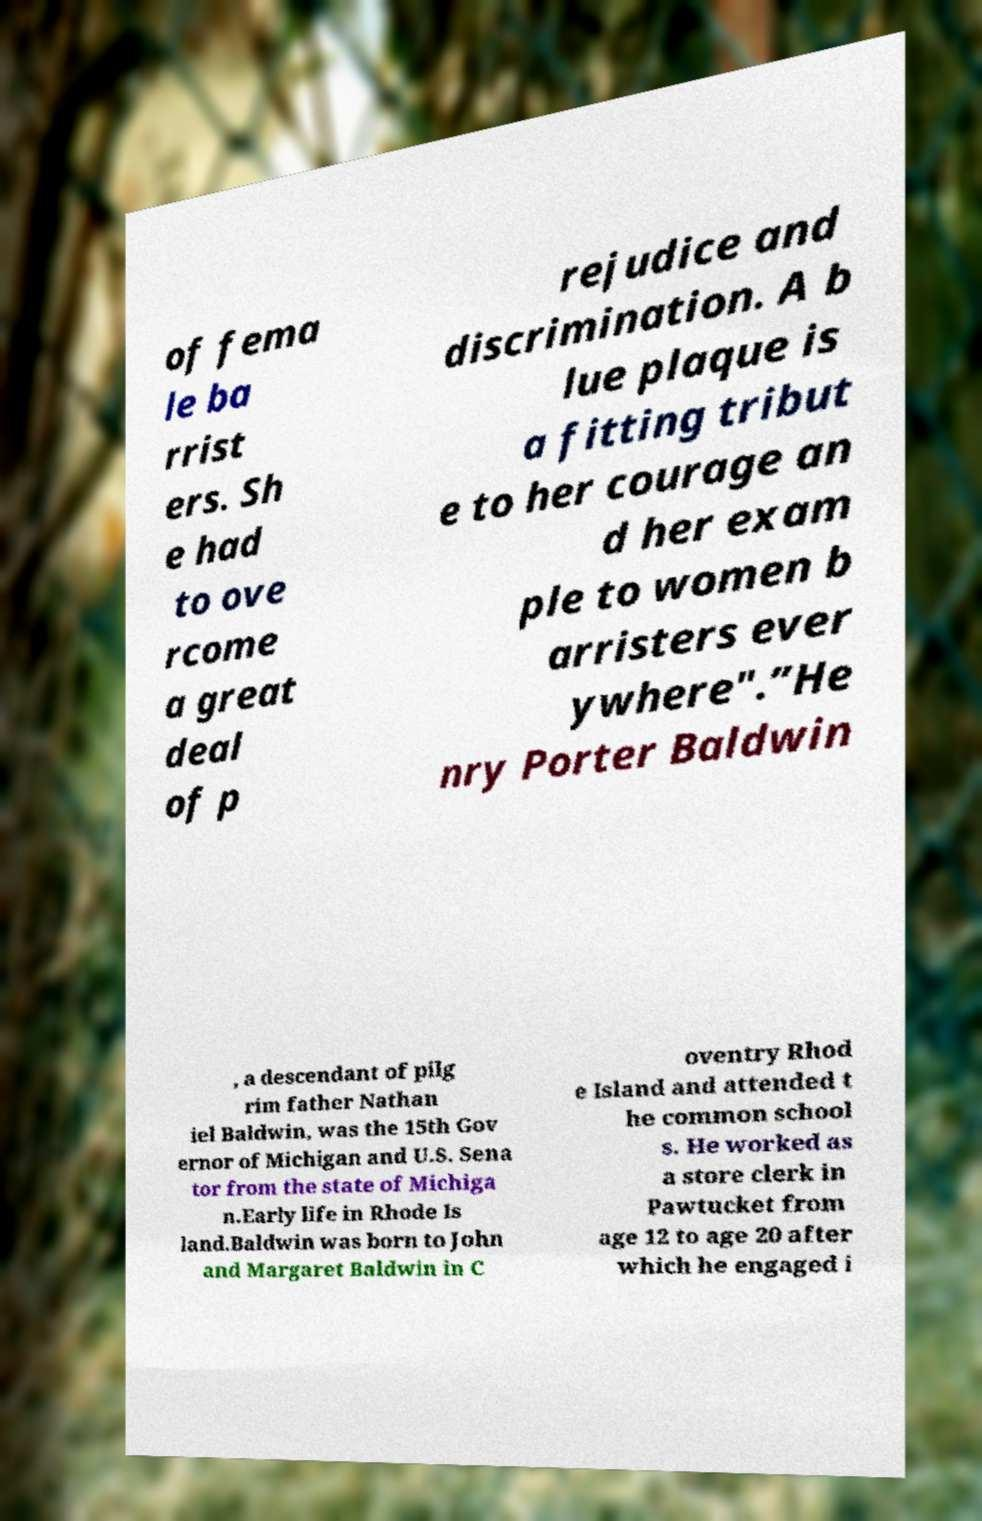Please read and relay the text visible in this image. What does it say? of fema le ba rrist ers. Sh e had to ove rcome a great deal of p rejudice and discrimination. A b lue plaque is a fitting tribut e to her courage an d her exam ple to women b arristers ever ywhere".”He nry Porter Baldwin , a descendant of pilg rim father Nathan iel Baldwin, was the 15th Gov ernor of Michigan and U.S. Sena tor from the state of Michiga n.Early life in Rhode Is land.Baldwin was born to John and Margaret Baldwin in C oventry Rhod e Island and attended t he common school s. He worked as a store clerk in Pawtucket from age 12 to age 20 after which he engaged i 